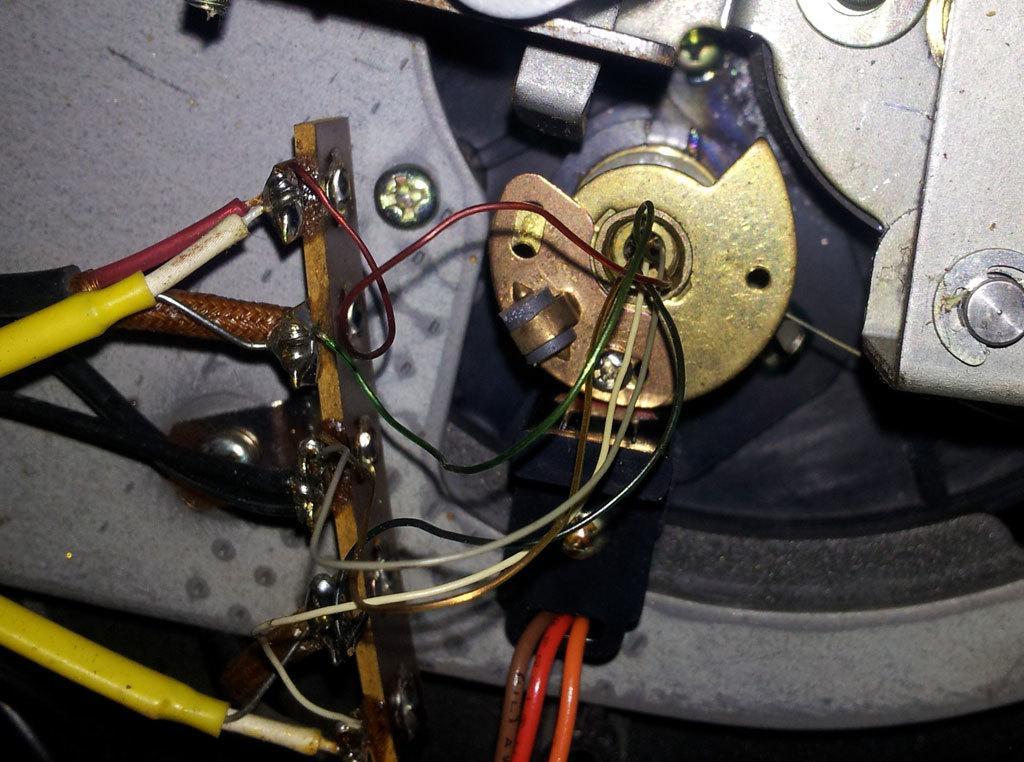Please provide a concise description of this image. In this image there is an object on the right side of this image and there are some wires connected to this object as we can see in middle of this image. There are some wires on the left side of this image. 